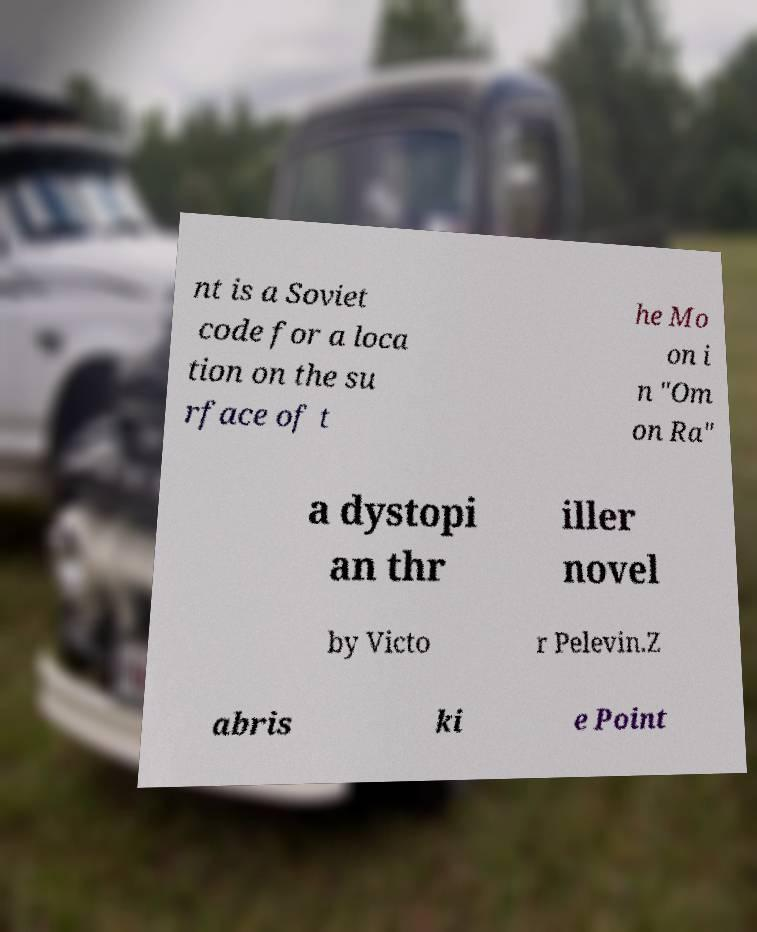Could you assist in decoding the text presented in this image and type it out clearly? nt is a Soviet code for a loca tion on the su rface of t he Mo on i n "Om on Ra" a dystopi an thr iller novel by Victo r Pelevin.Z abris ki e Point 